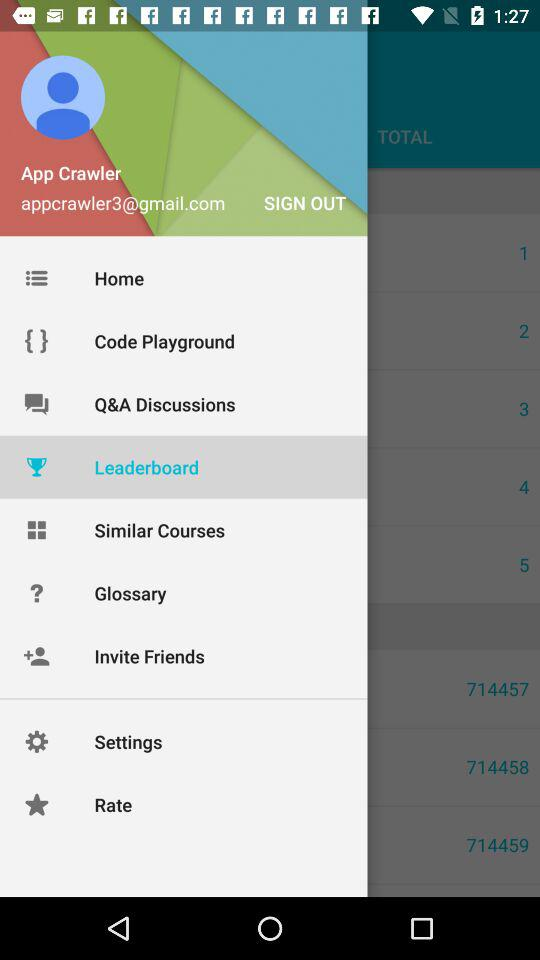What is the given email address? The given email address is appcrawler3@gmail.com. 